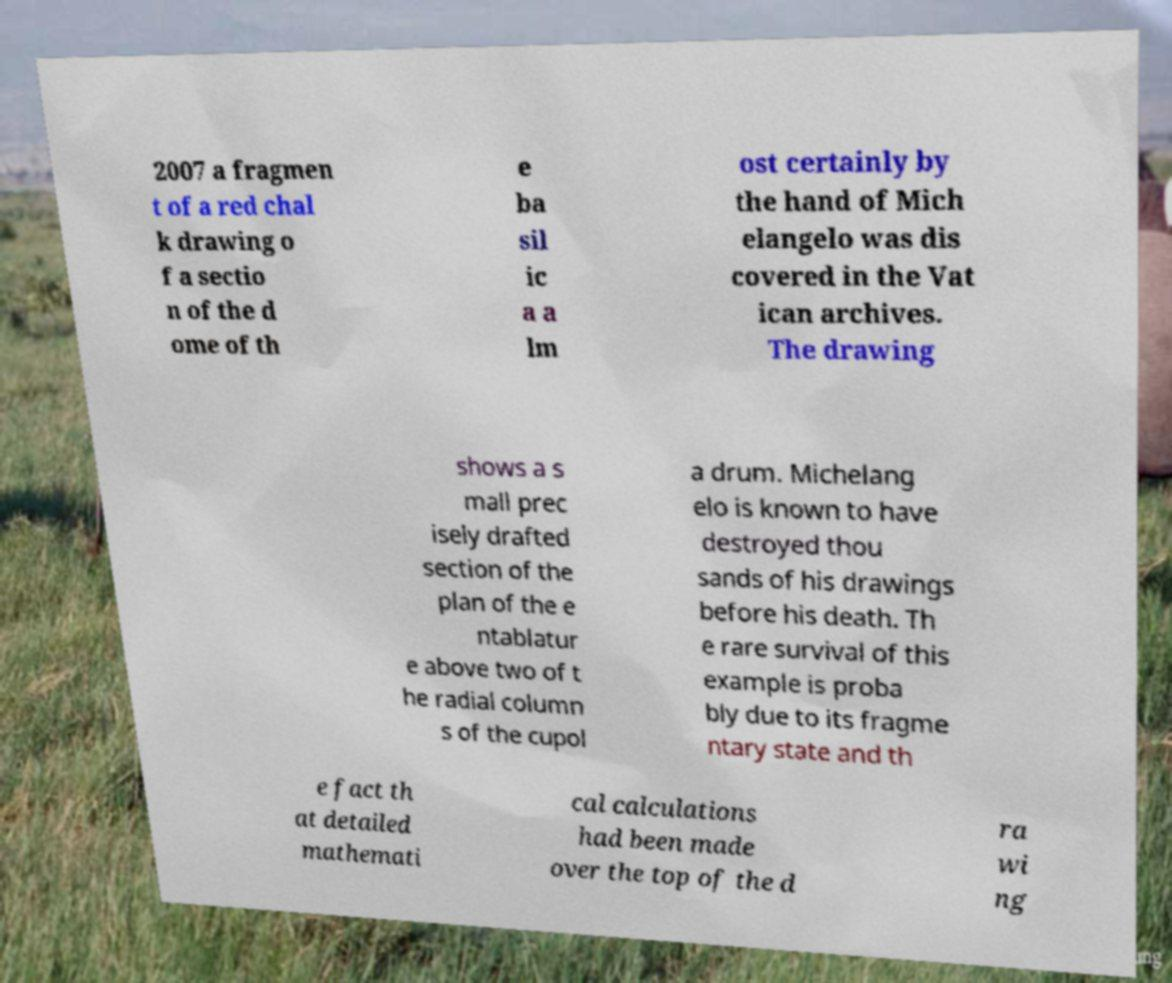Can you read and provide the text displayed in the image?This photo seems to have some interesting text. Can you extract and type it out for me? 2007 a fragmen t of a red chal k drawing o f a sectio n of the d ome of th e ba sil ic a a lm ost certainly by the hand of Mich elangelo was dis covered in the Vat ican archives. The drawing shows a s mall prec isely drafted section of the plan of the e ntablatur e above two of t he radial column s of the cupol a drum. Michelang elo is known to have destroyed thou sands of his drawings before his death. Th e rare survival of this example is proba bly due to its fragme ntary state and th e fact th at detailed mathemati cal calculations had been made over the top of the d ra wi ng 